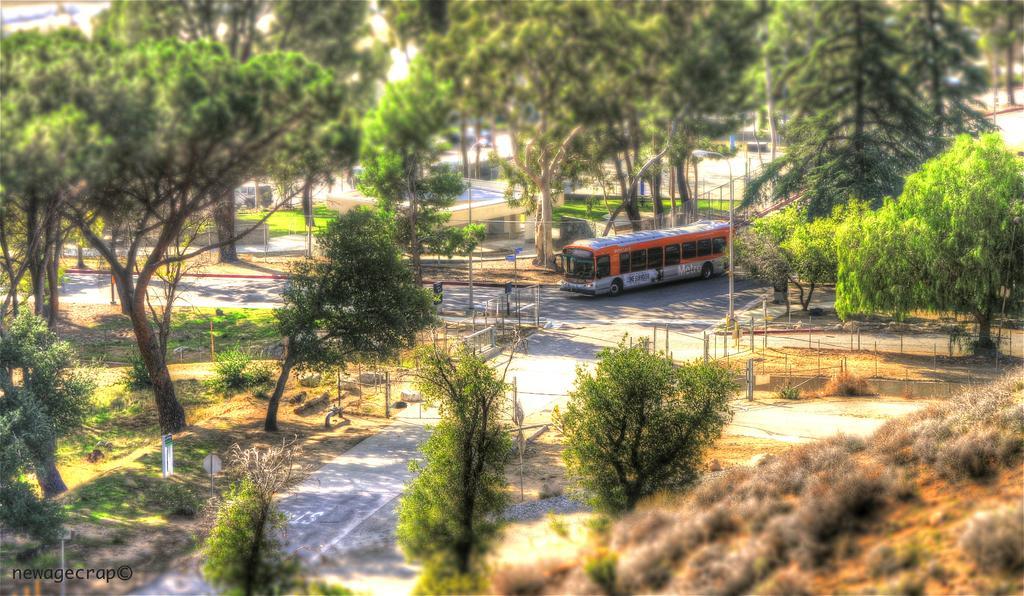Describe this image in one or two sentences. In this picture, we can see a road, vehicle, ground with grass, plants, trees, poles, fencing, boards, buildings, and the sky, we can see some watermark on bottom left side of the picture. 